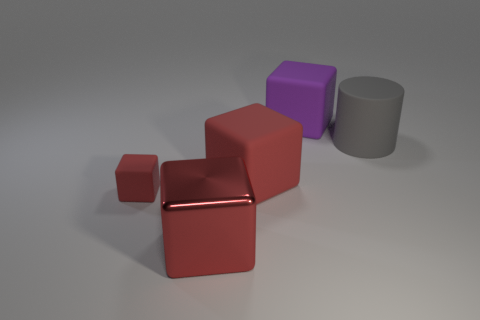Add 2 red shiny blocks. How many objects exist? 7 Subtract all red blocks. How many blocks are left? 1 Subtract 1 cylinders. How many cylinders are left? 0 Add 1 green metal objects. How many green metal objects exist? 1 Subtract all red cubes. How many cubes are left? 1 Subtract 0 brown spheres. How many objects are left? 5 Subtract all cylinders. How many objects are left? 4 Subtract all blue blocks. Subtract all brown spheres. How many blocks are left? 4 Subtract all purple cylinders. How many red cubes are left? 3 Subtract all small gray matte things. Subtract all red matte cubes. How many objects are left? 3 